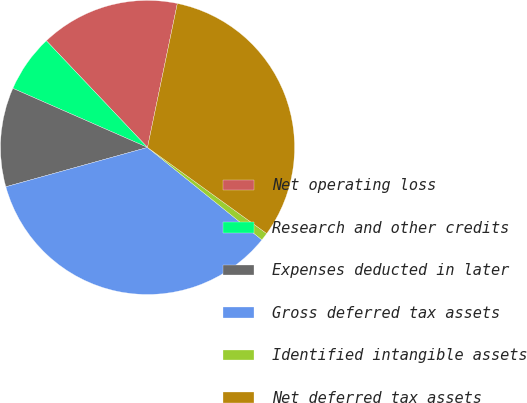Convert chart to OTSL. <chart><loc_0><loc_0><loc_500><loc_500><pie_chart><fcel>Net operating loss<fcel>Research and other credits<fcel>Expenses deducted in later<fcel>Gross deferred tax assets<fcel>Identified intangible assets<fcel>Net deferred tax assets<nl><fcel>15.33%<fcel>6.34%<fcel>10.89%<fcel>34.87%<fcel>0.86%<fcel>31.7%<nl></chart> 